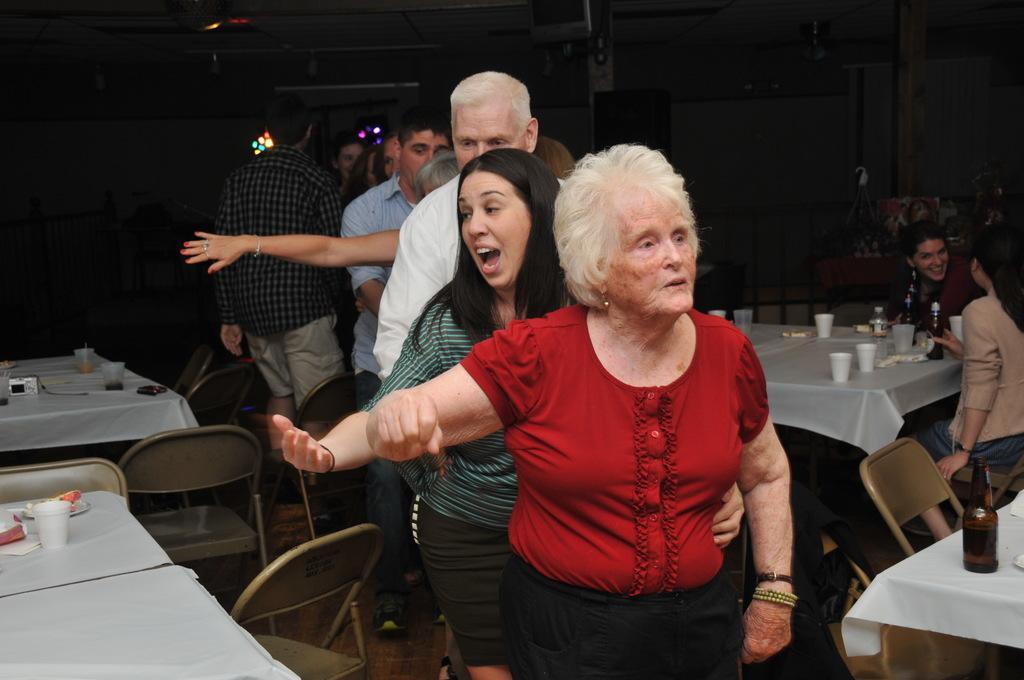Describe this image in one or two sentences. Background is very dark. These are lights. Here we can see tables and lights and on the tables we can see drinking glasses, camera, tissue paper , bottle. Here we can see two persons sitting on chairs. Here we can see few persons dancing. 